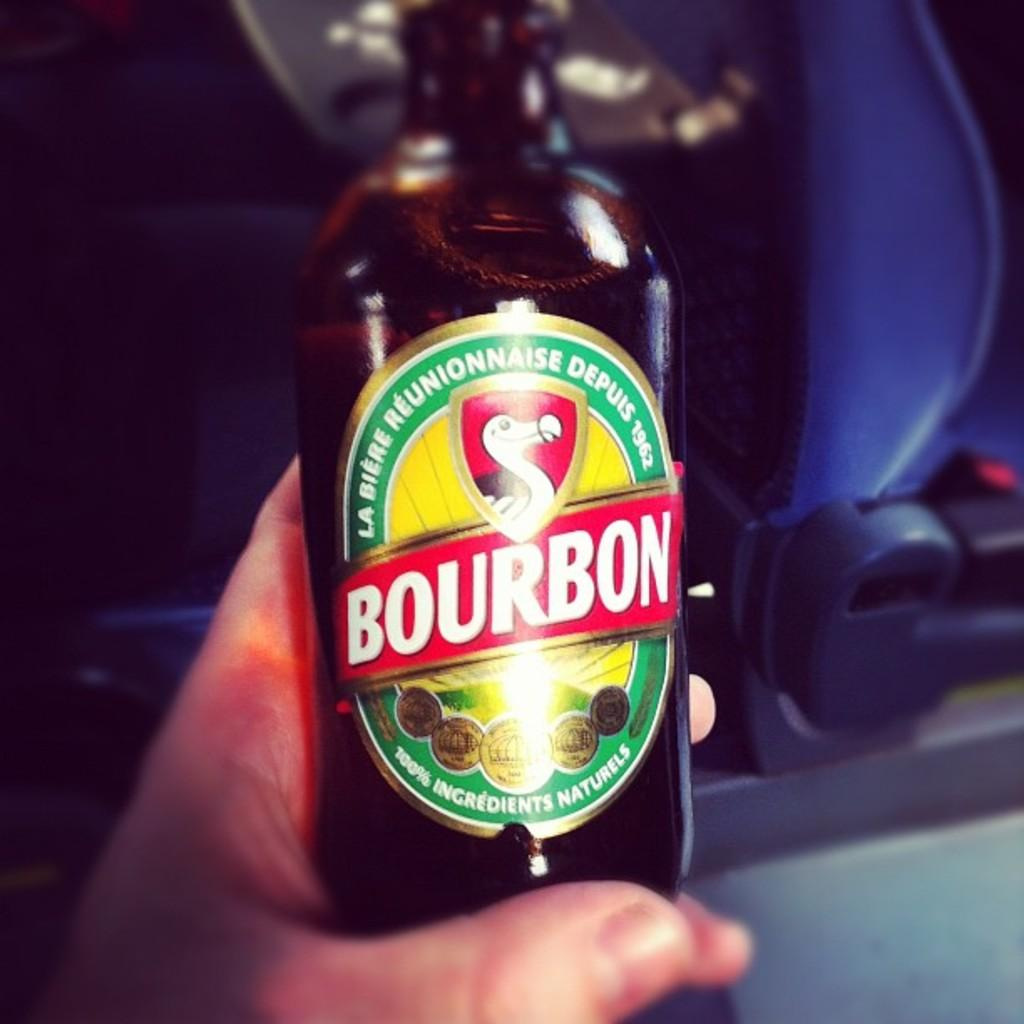<image>
Offer a succinct explanation of the picture presented. Someone holding a bottle of Bourbon next to a car seat 